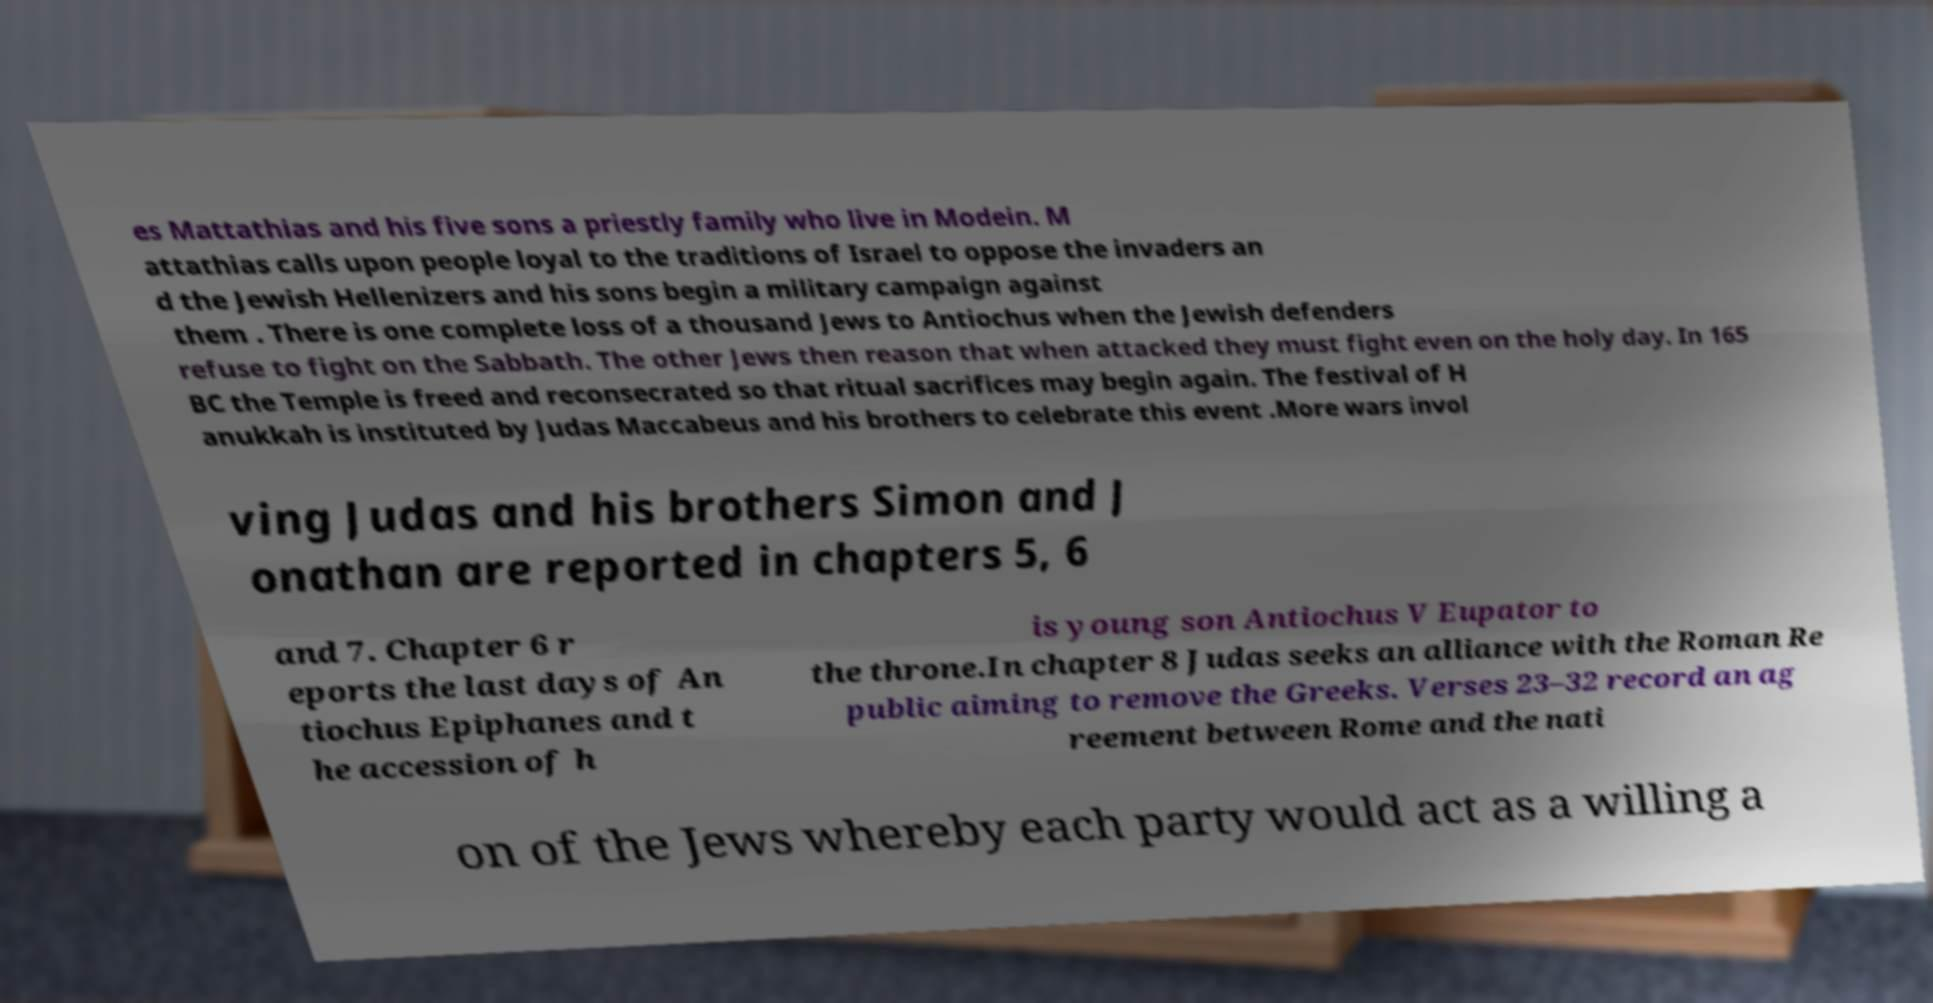There's text embedded in this image that I need extracted. Can you transcribe it verbatim? es Mattathias and his five sons a priestly family who live in Modein. M attathias calls upon people loyal to the traditions of Israel to oppose the invaders an d the Jewish Hellenizers and his sons begin a military campaign against them . There is one complete loss of a thousand Jews to Antiochus when the Jewish defenders refuse to fight on the Sabbath. The other Jews then reason that when attacked they must fight even on the holy day. In 165 BC the Temple is freed and reconsecrated so that ritual sacrifices may begin again. The festival of H anukkah is instituted by Judas Maccabeus and his brothers to celebrate this event .More wars invol ving Judas and his brothers Simon and J onathan are reported in chapters 5, 6 and 7. Chapter 6 r eports the last days of An tiochus Epiphanes and t he accession of h is young son Antiochus V Eupator to the throne.In chapter 8 Judas seeks an alliance with the Roman Re public aiming to remove the Greeks. Verses 23–32 record an ag reement between Rome and the nati on of the Jews whereby each party would act as a willing a 